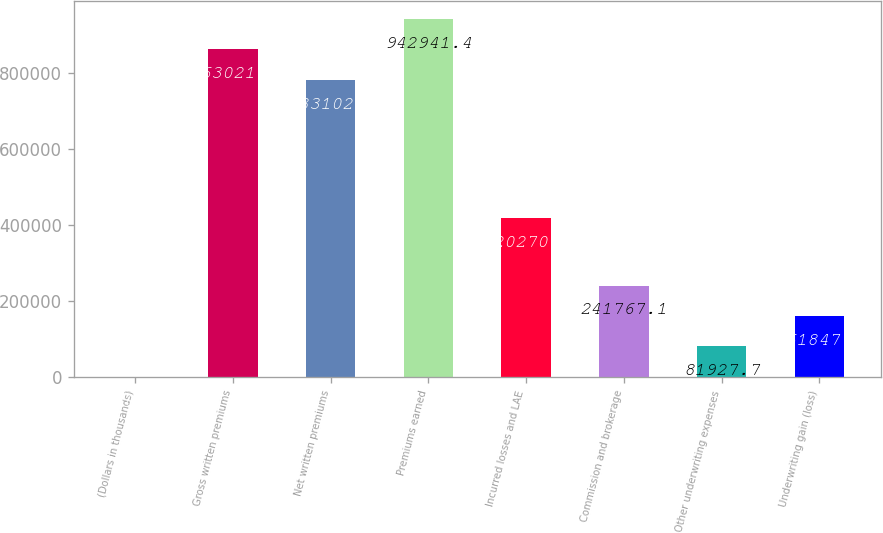Convert chart to OTSL. <chart><loc_0><loc_0><loc_500><loc_500><bar_chart><fcel>(Dollars in thousands)<fcel>Gross written premiums<fcel>Net written premiums<fcel>Premiums earned<fcel>Incurred losses and LAE<fcel>Commission and brokerage<fcel>Other underwriting expenses<fcel>Underwriting gain (loss)<nl><fcel>2008<fcel>863022<fcel>783102<fcel>942941<fcel>420270<fcel>241767<fcel>81927.7<fcel>161847<nl></chart> 